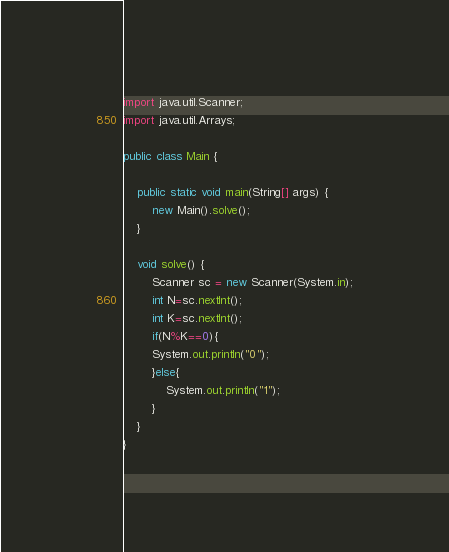<code> <loc_0><loc_0><loc_500><loc_500><_Java_>import java.util.Scanner;
import java.util.Arrays;

public class Main {

    public static void main(String[] args) {
        new Main().solve();
    }

    void solve() {
        Scanner sc = new Scanner(System.in);
        int N=sc.nextInt();
        int K=sc.nextInt();
        if(N%K==0){
        System.out.println("0");
        }else{
            System.out.println("1");
        }
    }
}</code> 